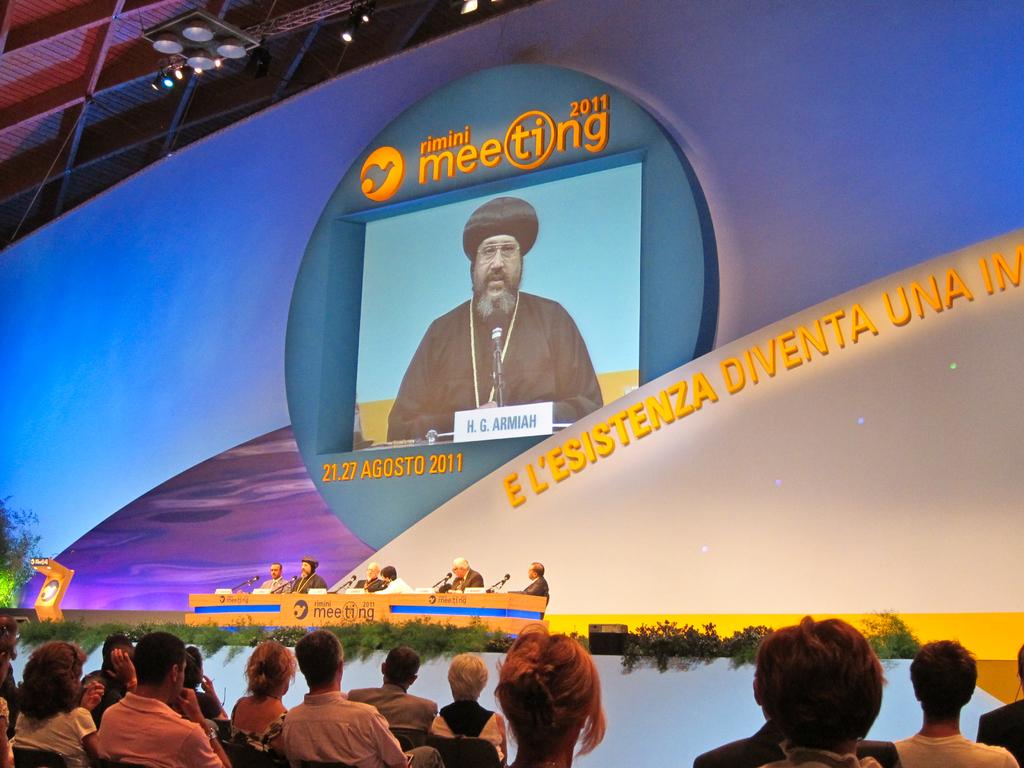What year is shown in the photo?
Keep it short and to the point. 2011. What type of meeting is it?
Offer a terse response. Rimini. 